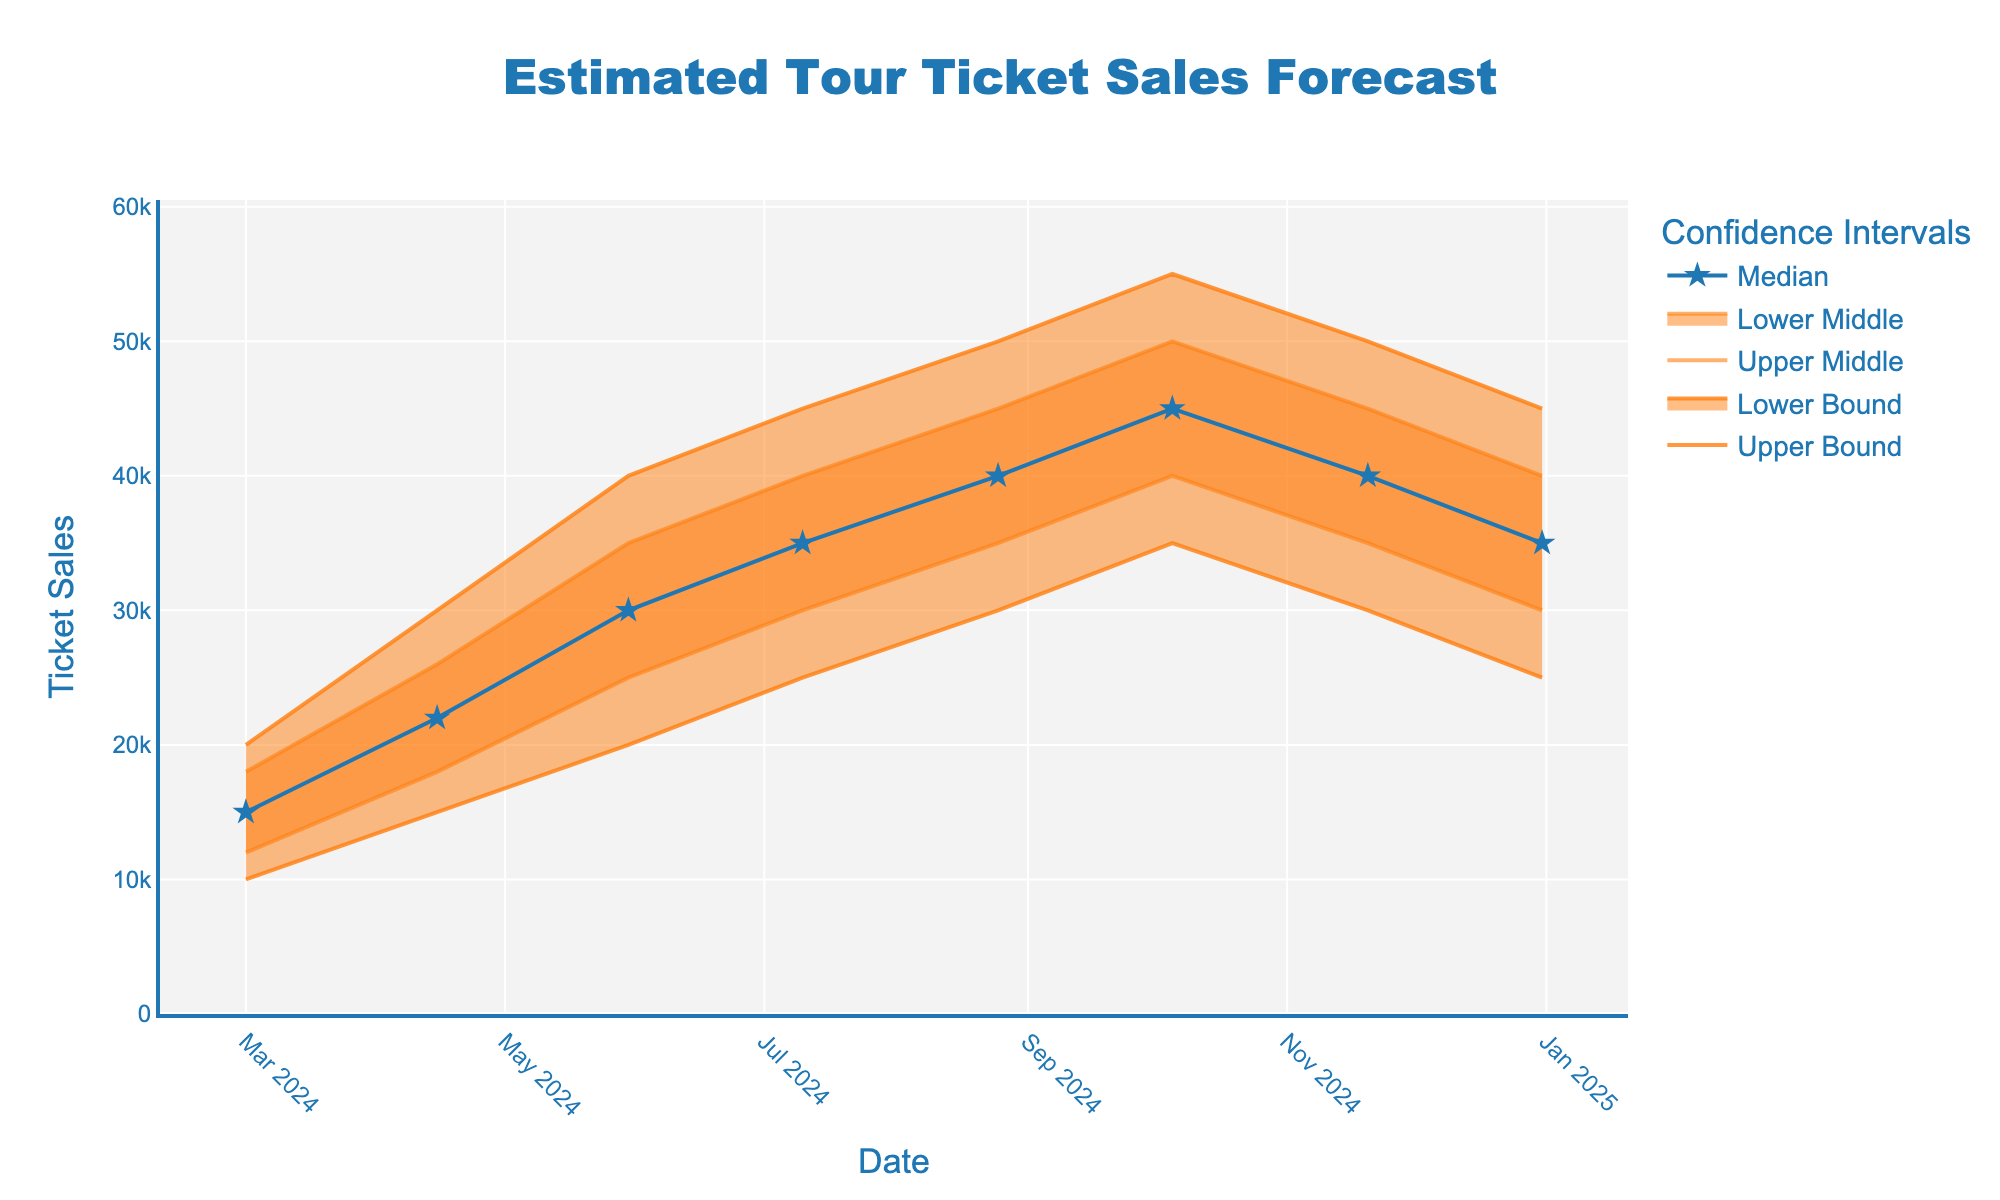what is the title of the chart? The title is displayed at the top and is usually the largest text in the chart. The title here is "Estimated Tour Ticket Sales Forecast".
Answer: Estimated Tour Ticket Sales Forecast What is the median value of ticket sales forecasted for August 25, 2024? The chart includes a line for the median values over various dates. On August 25, 2024, the median value is directly marked as 40000.
Answer: 40000 Which date shows the highest upper bound in ticket sales? The upper bound line is the topmost line on the chart, which peaks at the maximum value in October 2024. Referring to the data, October 5, 2024, shows the highest upper bound of 55000.
Answer: October 5, 2024 How does the median ticket sales change from March 1, 2024, to May 30, 2024? To find the change, look at the median lines on the dates specified. The median value on March 1, 2024, is 15000, while on May 30, 2024, it is 30000. Hence, the change is 30000 - 15000 = 15000.
Answer: Increases by 15000 Comparing the median ticket sales on July 10, 2024, and December 31, 2024, which one is higher? Check the median line for both dates. On July 10, 2024, the median is 35000, and on December 31, 2024, it is also 35000. Both values are equal.
Answer: Both are equal What is the difference between the upper middle and lower middle forecasts on October 5, 2024? For October 5, 2024, the upper middle value is 50000 and the lower middle value is 40000. The difference is 50000 - 40000 = 10000.
Answer: 10000 On which date do we see the widest range between the lower bound and upper bound ticket sales forecasts? The widest range is observed when the difference between the upper bound and lower bound is the greatest. On October 5, 2024, it ranges from 35000 (lower bound) to 55000 (upper bound), giving a range of 20000. No other dates have a wider range.
Answer: October 5, 2024 Is there any month where the ticket sales are expected to decrease in median value? If so, specify the month(s). Observing the median trend, the values decrease from August 25, 2024 (40000) to November 20, 2024 (40000) and then to December 31, 2024 (35000). Therefore, December sees a decrease.
Answer: December 